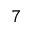<formula> <loc_0><loc_0><loc_500><loc_500>^ { 7 }</formula> 